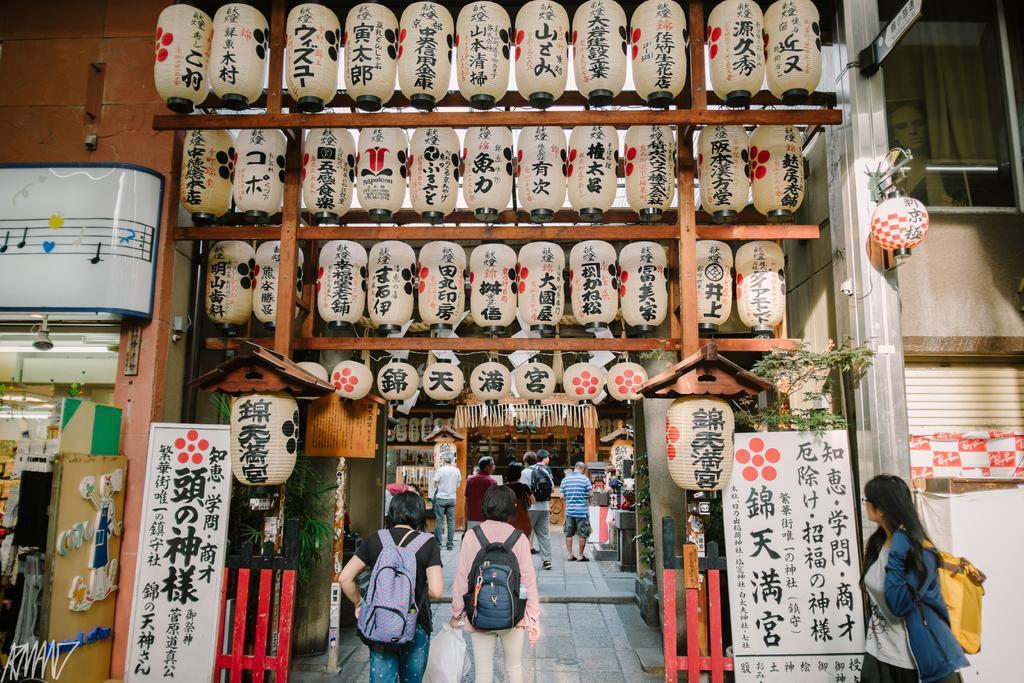Could you give a brief overview of what you see in this image? In this picture there are people and we can see boards, plants, wooden planks and objects. In the background of the image we can see store. On the right side of the image we can see shutter, wall, glass and banner. 